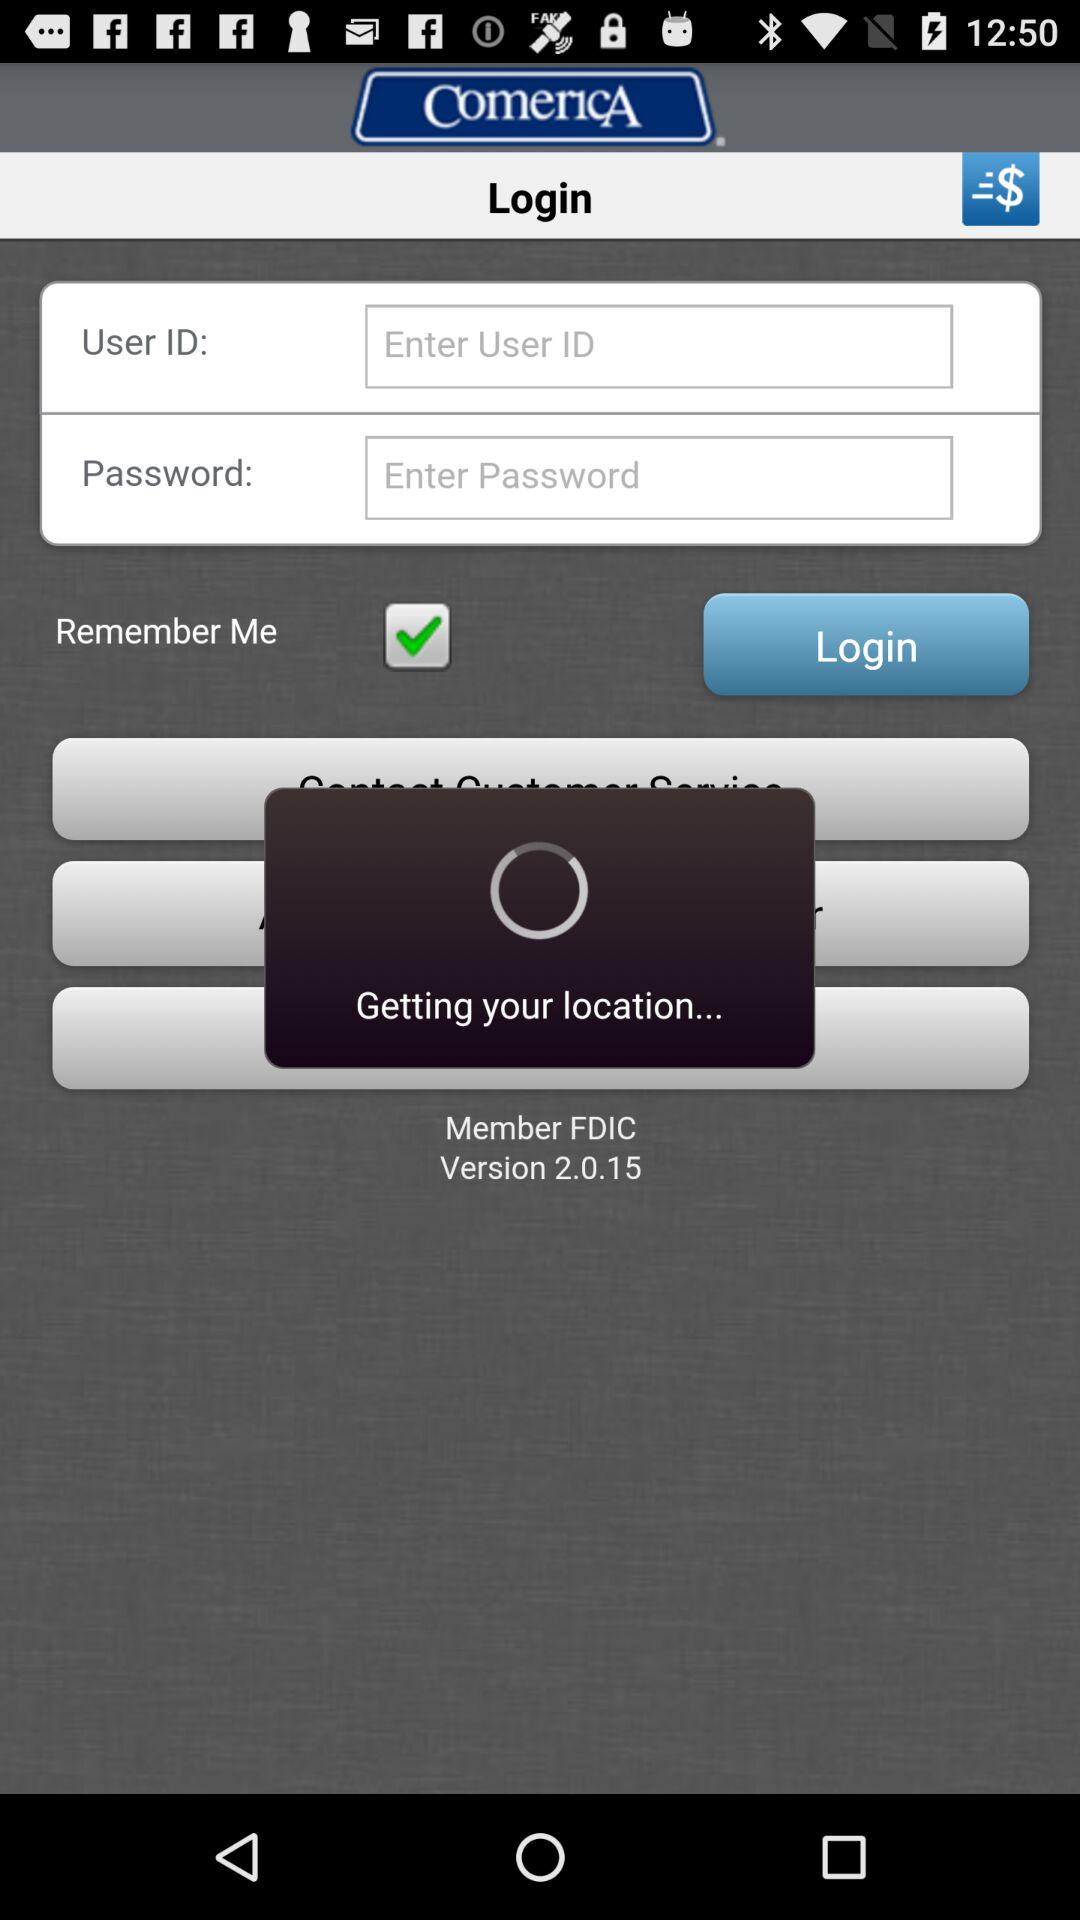How many search types are available?
Answer the question using a single word or phrase. 3 